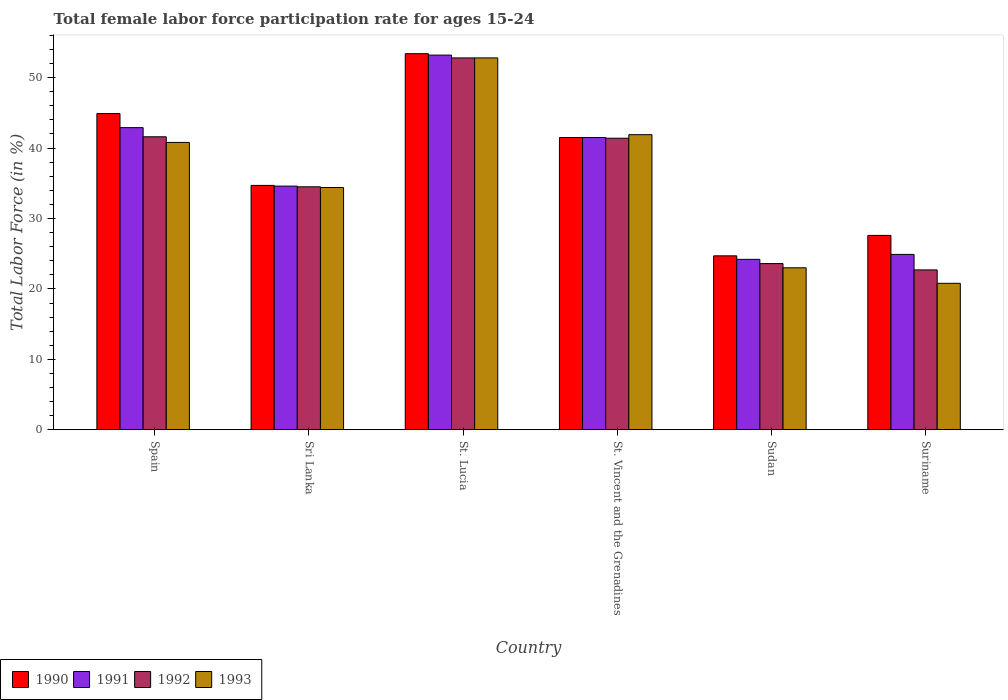How many groups of bars are there?
Make the answer very short. 6. Are the number of bars per tick equal to the number of legend labels?
Make the answer very short. Yes. Are the number of bars on each tick of the X-axis equal?
Your answer should be compact. Yes. How many bars are there on the 5th tick from the right?
Give a very brief answer. 4. What is the label of the 2nd group of bars from the left?
Provide a short and direct response. Sri Lanka. What is the female labor force participation rate in 1992 in Sri Lanka?
Offer a very short reply. 34.5. Across all countries, what is the maximum female labor force participation rate in 1991?
Your answer should be compact. 53.2. Across all countries, what is the minimum female labor force participation rate in 1990?
Make the answer very short. 24.7. In which country was the female labor force participation rate in 1990 maximum?
Offer a very short reply. St. Lucia. In which country was the female labor force participation rate in 1990 minimum?
Provide a succinct answer. Sudan. What is the total female labor force participation rate in 1991 in the graph?
Offer a very short reply. 221.3. What is the difference between the female labor force participation rate in 1992 in Spain and that in Suriname?
Offer a terse response. 18.9. What is the difference between the female labor force participation rate in 1991 in Sri Lanka and the female labor force participation rate in 1990 in Spain?
Provide a succinct answer. -10.3. What is the average female labor force participation rate in 1992 per country?
Ensure brevity in your answer.  36.1. What is the difference between the female labor force participation rate of/in 1991 and female labor force participation rate of/in 1992 in Suriname?
Offer a very short reply. 2.2. What is the ratio of the female labor force participation rate in 1991 in Sri Lanka to that in St. Vincent and the Grenadines?
Make the answer very short. 0.83. Is the female labor force participation rate in 1991 in Spain less than that in Sudan?
Your response must be concise. No. What is the difference between the highest and the second highest female labor force participation rate in 1993?
Keep it short and to the point. -1.1. What is the difference between the highest and the lowest female labor force participation rate in 1992?
Make the answer very short. 30.1. In how many countries, is the female labor force participation rate in 1991 greater than the average female labor force participation rate in 1991 taken over all countries?
Your response must be concise. 3. What does the 3rd bar from the left in Sudan represents?
Keep it short and to the point. 1992. Is it the case that in every country, the sum of the female labor force participation rate in 1993 and female labor force participation rate in 1992 is greater than the female labor force participation rate in 1990?
Your response must be concise. Yes. How many bars are there?
Ensure brevity in your answer.  24. What is the difference between two consecutive major ticks on the Y-axis?
Ensure brevity in your answer.  10. Are the values on the major ticks of Y-axis written in scientific E-notation?
Offer a terse response. No. How many legend labels are there?
Your response must be concise. 4. What is the title of the graph?
Your answer should be very brief. Total female labor force participation rate for ages 15-24. What is the label or title of the X-axis?
Provide a succinct answer. Country. What is the label or title of the Y-axis?
Make the answer very short. Total Labor Force (in %). What is the Total Labor Force (in %) in 1990 in Spain?
Offer a terse response. 44.9. What is the Total Labor Force (in %) of 1991 in Spain?
Your answer should be compact. 42.9. What is the Total Labor Force (in %) in 1992 in Spain?
Offer a very short reply. 41.6. What is the Total Labor Force (in %) of 1993 in Spain?
Make the answer very short. 40.8. What is the Total Labor Force (in %) of 1990 in Sri Lanka?
Your answer should be compact. 34.7. What is the Total Labor Force (in %) of 1991 in Sri Lanka?
Give a very brief answer. 34.6. What is the Total Labor Force (in %) in 1992 in Sri Lanka?
Give a very brief answer. 34.5. What is the Total Labor Force (in %) of 1993 in Sri Lanka?
Offer a terse response. 34.4. What is the Total Labor Force (in %) in 1990 in St. Lucia?
Provide a succinct answer. 53.4. What is the Total Labor Force (in %) of 1991 in St. Lucia?
Keep it short and to the point. 53.2. What is the Total Labor Force (in %) in 1992 in St. Lucia?
Make the answer very short. 52.8. What is the Total Labor Force (in %) in 1993 in St. Lucia?
Make the answer very short. 52.8. What is the Total Labor Force (in %) in 1990 in St. Vincent and the Grenadines?
Provide a succinct answer. 41.5. What is the Total Labor Force (in %) in 1991 in St. Vincent and the Grenadines?
Keep it short and to the point. 41.5. What is the Total Labor Force (in %) in 1992 in St. Vincent and the Grenadines?
Offer a very short reply. 41.4. What is the Total Labor Force (in %) of 1993 in St. Vincent and the Grenadines?
Give a very brief answer. 41.9. What is the Total Labor Force (in %) of 1990 in Sudan?
Your response must be concise. 24.7. What is the Total Labor Force (in %) of 1991 in Sudan?
Ensure brevity in your answer.  24.2. What is the Total Labor Force (in %) of 1992 in Sudan?
Offer a very short reply. 23.6. What is the Total Labor Force (in %) in 1993 in Sudan?
Your answer should be very brief. 23. What is the Total Labor Force (in %) in 1990 in Suriname?
Make the answer very short. 27.6. What is the Total Labor Force (in %) of 1991 in Suriname?
Offer a terse response. 24.9. What is the Total Labor Force (in %) in 1992 in Suriname?
Provide a short and direct response. 22.7. What is the Total Labor Force (in %) in 1993 in Suriname?
Offer a terse response. 20.8. Across all countries, what is the maximum Total Labor Force (in %) in 1990?
Your answer should be compact. 53.4. Across all countries, what is the maximum Total Labor Force (in %) in 1991?
Offer a very short reply. 53.2. Across all countries, what is the maximum Total Labor Force (in %) of 1992?
Your answer should be compact. 52.8. Across all countries, what is the maximum Total Labor Force (in %) of 1993?
Your answer should be compact. 52.8. Across all countries, what is the minimum Total Labor Force (in %) in 1990?
Make the answer very short. 24.7. Across all countries, what is the minimum Total Labor Force (in %) of 1991?
Offer a very short reply. 24.2. Across all countries, what is the minimum Total Labor Force (in %) of 1992?
Provide a succinct answer. 22.7. Across all countries, what is the minimum Total Labor Force (in %) of 1993?
Keep it short and to the point. 20.8. What is the total Total Labor Force (in %) of 1990 in the graph?
Give a very brief answer. 226.8. What is the total Total Labor Force (in %) of 1991 in the graph?
Provide a short and direct response. 221.3. What is the total Total Labor Force (in %) of 1992 in the graph?
Your answer should be compact. 216.6. What is the total Total Labor Force (in %) in 1993 in the graph?
Your response must be concise. 213.7. What is the difference between the Total Labor Force (in %) of 1990 in Spain and that in Sri Lanka?
Offer a terse response. 10.2. What is the difference between the Total Labor Force (in %) in 1990 in Spain and that in St. Lucia?
Provide a short and direct response. -8.5. What is the difference between the Total Labor Force (in %) of 1991 in Spain and that in St. Lucia?
Offer a terse response. -10.3. What is the difference between the Total Labor Force (in %) in 1992 in Spain and that in St. Lucia?
Your response must be concise. -11.2. What is the difference between the Total Labor Force (in %) in 1993 in Spain and that in St. Lucia?
Provide a short and direct response. -12. What is the difference between the Total Labor Force (in %) in 1991 in Spain and that in St. Vincent and the Grenadines?
Ensure brevity in your answer.  1.4. What is the difference between the Total Labor Force (in %) of 1992 in Spain and that in St. Vincent and the Grenadines?
Make the answer very short. 0.2. What is the difference between the Total Labor Force (in %) of 1993 in Spain and that in St. Vincent and the Grenadines?
Keep it short and to the point. -1.1. What is the difference between the Total Labor Force (in %) of 1990 in Spain and that in Sudan?
Your answer should be compact. 20.2. What is the difference between the Total Labor Force (in %) in 1992 in Spain and that in Sudan?
Offer a very short reply. 18. What is the difference between the Total Labor Force (in %) in 1990 in Spain and that in Suriname?
Provide a succinct answer. 17.3. What is the difference between the Total Labor Force (in %) of 1992 in Spain and that in Suriname?
Offer a very short reply. 18.9. What is the difference between the Total Labor Force (in %) in 1990 in Sri Lanka and that in St. Lucia?
Offer a terse response. -18.7. What is the difference between the Total Labor Force (in %) of 1991 in Sri Lanka and that in St. Lucia?
Give a very brief answer. -18.6. What is the difference between the Total Labor Force (in %) in 1992 in Sri Lanka and that in St. Lucia?
Give a very brief answer. -18.3. What is the difference between the Total Labor Force (in %) of 1993 in Sri Lanka and that in St. Lucia?
Make the answer very short. -18.4. What is the difference between the Total Labor Force (in %) of 1991 in Sri Lanka and that in St. Vincent and the Grenadines?
Keep it short and to the point. -6.9. What is the difference between the Total Labor Force (in %) of 1992 in Sri Lanka and that in St. Vincent and the Grenadines?
Ensure brevity in your answer.  -6.9. What is the difference between the Total Labor Force (in %) in 1993 in Sri Lanka and that in St. Vincent and the Grenadines?
Your response must be concise. -7.5. What is the difference between the Total Labor Force (in %) of 1991 in Sri Lanka and that in Sudan?
Ensure brevity in your answer.  10.4. What is the difference between the Total Labor Force (in %) in 1992 in Sri Lanka and that in Sudan?
Your response must be concise. 10.9. What is the difference between the Total Labor Force (in %) in 1993 in Sri Lanka and that in Sudan?
Your response must be concise. 11.4. What is the difference between the Total Labor Force (in %) of 1990 in Sri Lanka and that in Suriname?
Provide a short and direct response. 7.1. What is the difference between the Total Labor Force (in %) in 1991 in Sri Lanka and that in Suriname?
Provide a short and direct response. 9.7. What is the difference between the Total Labor Force (in %) of 1992 in Sri Lanka and that in Suriname?
Your response must be concise. 11.8. What is the difference between the Total Labor Force (in %) in 1990 in St. Lucia and that in St. Vincent and the Grenadines?
Give a very brief answer. 11.9. What is the difference between the Total Labor Force (in %) of 1992 in St. Lucia and that in St. Vincent and the Grenadines?
Offer a terse response. 11.4. What is the difference between the Total Labor Force (in %) in 1990 in St. Lucia and that in Sudan?
Provide a short and direct response. 28.7. What is the difference between the Total Labor Force (in %) of 1992 in St. Lucia and that in Sudan?
Your answer should be very brief. 29.2. What is the difference between the Total Labor Force (in %) in 1993 in St. Lucia and that in Sudan?
Your response must be concise. 29.8. What is the difference between the Total Labor Force (in %) in 1990 in St. Lucia and that in Suriname?
Your response must be concise. 25.8. What is the difference between the Total Labor Force (in %) of 1991 in St. Lucia and that in Suriname?
Offer a very short reply. 28.3. What is the difference between the Total Labor Force (in %) in 1992 in St. Lucia and that in Suriname?
Provide a succinct answer. 30.1. What is the difference between the Total Labor Force (in %) of 1990 in St. Vincent and the Grenadines and that in Sudan?
Keep it short and to the point. 16.8. What is the difference between the Total Labor Force (in %) of 1991 in St. Vincent and the Grenadines and that in Sudan?
Provide a short and direct response. 17.3. What is the difference between the Total Labor Force (in %) of 1990 in St. Vincent and the Grenadines and that in Suriname?
Offer a terse response. 13.9. What is the difference between the Total Labor Force (in %) of 1992 in St. Vincent and the Grenadines and that in Suriname?
Your answer should be very brief. 18.7. What is the difference between the Total Labor Force (in %) of 1993 in St. Vincent and the Grenadines and that in Suriname?
Your answer should be compact. 21.1. What is the difference between the Total Labor Force (in %) of 1990 in Sudan and that in Suriname?
Give a very brief answer. -2.9. What is the difference between the Total Labor Force (in %) of 1993 in Sudan and that in Suriname?
Ensure brevity in your answer.  2.2. What is the difference between the Total Labor Force (in %) in 1990 in Spain and the Total Labor Force (in %) in 1993 in Sri Lanka?
Offer a very short reply. 10.5. What is the difference between the Total Labor Force (in %) of 1991 in Spain and the Total Labor Force (in %) of 1993 in Sri Lanka?
Offer a terse response. 8.5. What is the difference between the Total Labor Force (in %) of 1990 in Spain and the Total Labor Force (in %) of 1991 in St. Lucia?
Your response must be concise. -8.3. What is the difference between the Total Labor Force (in %) in 1990 in Spain and the Total Labor Force (in %) in 1993 in St. Lucia?
Offer a terse response. -7.9. What is the difference between the Total Labor Force (in %) of 1991 in Spain and the Total Labor Force (in %) of 1992 in St. Lucia?
Your answer should be very brief. -9.9. What is the difference between the Total Labor Force (in %) in 1991 in Spain and the Total Labor Force (in %) in 1993 in St. Lucia?
Provide a succinct answer. -9.9. What is the difference between the Total Labor Force (in %) in 1990 in Spain and the Total Labor Force (in %) in 1992 in St. Vincent and the Grenadines?
Provide a succinct answer. 3.5. What is the difference between the Total Labor Force (in %) of 1991 in Spain and the Total Labor Force (in %) of 1992 in St. Vincent and the Grenadines?
Keep it short and to the point. 1.5. What is the difference between the Total Labor Force (in %) of 1990 in Spain and the Total Labor Force (in %) of 1991 in Sudan?
Keep it short and to the point. 20.7. What is the difference between the Total Labor Force (in %) in 1990 in Spain and the Total Labor Force (in %) in 1992 in Sudan?
Offer a terse response. 21.3. What is the difference between the Total Labor Force (in %) in 1990 in Spain and the Total Labor Force (in %) in 1993 in Sudan?
Your answer should be very brief. 21.9. What is the difference between the Total Labor Force (in %) in 1991 in Spain and the Total Labor Force (in %) in 1992 in Sudan?
Your answer should be compact. 19.3. What is the difference between the Total Labor Force (in %) in 1991 in Spain and the Total Labor Force (in %) in 1993 in Sudan?
Keep it short and to the point. 19.9. What is the difference between the Total Labor Force (in %) of 1990 in Spain and the Total Labor Force (in %) of 1992 in Suriname?
Your answer should be very brief. 22.2. What is the difference between the Total Labor Force (in %) of 1990 in Spain and the Total Labor Force (in %) of 1993 in Suriname?
Provide a short and direct response. 24.1. What is the difference between the Total Labor Force (in %) of 1991 in Spain and the Total Labor Force (in %) of 1992 in Suriname?
Your answer should be compact. 20.2. What is the difference between the Total Labor Force (in %) of 1991 in Spain and the Total Labor Force (in %) of 1993 in Suriname?
Offer a terse response. 22.1. What is the difference between the Total Labor Force (in %) of 1992 in Spain and the Total Labor Force (in %) of 1993 in Suriname?
Provide a succinct answer. 20.8. What is the difference between the Total Labor Force (in %) in 1990 in Sri Lanka and the Total Labor Force (in %) in 1991 in St. Lucia?
Offer a terse response. -18.5. What is the difference between the Total Labor Force (in %) of 1990 in Sri Lanka and the Total Labor Force (in %) of 1992 in St. Lucia?
Offer a terse response. -18.1. What is the difference between the Total Labor Force (in %) in 1990 in Sri Lanka and the Total Labor Force (in %) in 1993 in St. Lucia?
Give a very brief answer. -18.1. What is the difference between the Total Labor Force (in %) in 1991 in Sri Lanka and the Total Labor Force (in %) in 1992 in St. Lucia?
Provide a succinct answer. -18.2. What is the difference between the Total Labor Force (in %) in 1991 in Sri Lanka and the Total Labor Force (in %) in 1993 in St. Lucia?
Ensure brevity in your answer.  -18.2. What is the difference between the Total Labor Force (in %) of 1992 in Sri Lanka and the Total Labor Force (in %) of 1993 in St. Lucia?
Ensure brevity in your answer.  -18.3. What is the difference between the Total Labor Force (in %) of 1990 in Sri Lanka and the Total Labor Force (in %) of 1991 in St. Vincent and the Grenadines?
Provide a short and direct response. -6.8. What is the difference between the Total Labor Force (in %) of 1991 in Sri Lanka and the Total Labor Force (in %) of 1992 in St. Vincent and the Grenadines?
Offer a very short reply. -6.8. What is the difference between the Total Labor Force (in %) of 1990 in Sri Lanka and the Total Labor Force (in %) of 1991 in Sudan?
Offer a terse response. 10.5. What is the difference between the Total Labor Force (in %) of 1990 in Sri Lanka and the Total Labor Force (in %) of 1992 in Sudan?
Keep it short and to the point. 11.1. What is the difference between the Total Labor Force (in %) of 1990 in Sri Lanka and the Total Labor Force (in %) of 1993 in Sudan?
Provide a succinct answer. 11.7. What is the difference between the Total Labor Force (in %) of 1992 in Sri Lanka and the Total Labor Force (in %) of 1993 in Sudan?
Ensure brevity in your answer.  11.5. What is the difference between the Total Labor Force (in %) of 1990 in Sri Lanka and the Total Labor Force (in %) of 1991 in Suriname?
Ensure brevity in your answer.  9.8. What is the difference between the Total Labor Force (in %) of 1990 in Sri Lanka and the Total Labor Force (in %) of 1992 in Suriname?
Give a very brief answer. 12. What is the difference between the Total Labor Force (in %) in 1990 in Sri Lanka and the Total Labor Force (in %) in 1993 in Suriname?
Provide a succinct answer. 13.9. What is the difference between the Total Labor Force (in %) of 1991 in Sri Lanka and the Total Labor Force (in %) of 1992 in Suriname?
Keep it short and to the point. 11.9. What is the difference between the Total Labor Force (in %) of 1991 in Sri Lanka and the Total Labor Force (in %) of 1993 in Suriname?
Give a very brief answer. 13.8. What is the difference between the Total Labor Force (in %) in 1992 in Sri Lanka and the Total Labor Force (in %) in 1993 in Suriname?
Keep it short and to the point. 13.7. What is the difference between the Total Labor Force (in %) of 1990 in St. Lucia and the Total Labor Force (in %) of 1993 in St. Vincent and the Grenadines?
Offer a very short reply. 11.5. What is the difference between the Total Labor Force (in %) in 1991 in St. Lucia and the Total Labor Force (in %) in 1992 in St. Vincent and the Grenadines?
Offer a very short reply. 11.8. What is the difference between the Total Labor Force (in %) in 1991 in St. Lucia and the Total Labor Force (in %) in 1993 in St. Vincent and the Grenadines?
Offer a very short reply. 11.3. What is the difference between the Total Labor Force (in %) of 1992 in St. Lucia and the Total Labor Force (in %) of 1993 in St. Vincent and the Grenadines?
Ensure brevity in your answer.  10.9. What is the difference between the Total Labor Force (in %) in 1990 in St. Lucia and the Total Labor Force (in %) in 1991 in Sudan?
Make the answer very short. 29.2. What is the difference between the Total Labor Force (in %) in 1990 in St. Lucia and the Total Labor Force (in %) in 1992 in Sudan?
Offer a terse response. 29.8. What is the difference between the Total Labor Force (in %) of 1990 in St. Lucia and the Total Labor Force (in %) of 1993 in Sudan?
Your response must be concise. 30.4. What is the difference between the Total Labor Force (in %) in 1991 in St. Lucia and the Total Labor Force (in %) in 1992 in Sudan?
Your response must be concise. 29.6. What is the difference between the Total Labor Force (in %) of 1991 in St. Lucia and the Total Labor Force (in %) of 1993 in Sudan?
Give a very brief answer. 30.2. What is the difference between the Total Labor Force (in %) of 1992 in St. Lucia and the Total Labor Force (in %) of 1993 in Sudan?
Your response must be concise. 29.8. What is the difference between the Total Labor Force (in %) of 1990 in St. Lucia and the Total Labor Force (in %) of 1992 in Suriname?
Ensure brevity in your answer.  30.7. What is the difference between the Total Labor Force (in %) in 1990 in St. Lucia and the Total Labor Force (in %) in 1993 in Suriname?
Give a very brief answer. 32.6. What is the difference between the Total Labor Force (in %) in 1991 in St. Lucia and the Total Labor Force (in %) in 1992 in Suriname?
Ensure brevity in your answer.  30.5. What is the difference between the Total Labor Force (in %) in 1991 in St. Lucia and the Total Labor Force (in %) in 1993 in Suriname?
Keep it short and to the point. 32.4. What is the difference between the Total Labor Force (in %) in 1992 in St. Lucia and the Total Labor Force (in %) in 1993 in Suriname?
Provide a short and direct response. 32. What is the difference between the Total Labor Force (in %) of 1990 in St. Vincent and the Grenadines and the Total Labor Force (in %) of 1991 in Sudan?
Provide a short and direct response. 17.3. What is the difference between the Total Labor Force (in %) of 1990 in St. Vincent and the Grenadines and the Total Labor Force (in %) of 1993 in Sudan?
Provide a succinct answer. 18.5. What is the difference between the Total Labor Force (in %) of 1991 in St. Vincent and the Grenadines and the Total Labor Force (in %) of 1992 in Sudan?
Your answer should be compact. 17.9. What is the difference between the Total Labor Force (in %) of 1991 in St. Vincent and the Grenadines and the Total Labor Force (in %) of 1993 in Sudan?
Provide a short and direct response. 18.5. What is the difference between the Total Labor Force (in %) in 1990 in St. Vincent and the Grenadines and the Total Labor Force (in %) in 1991 in Suriname?
Provide a succinct answer. 16.6. What is the difference between the Total Labor Force (in %) of 1990 in St. Vincent and the Grenadines and the Total Labor Force (in %) of 1992 in Suriname?
Offer a very short reply. 18.8. What is the difference between the Total Labor Force (in %) of 1990 in St. Vincent and the Grenadines and the Total Labor Force (in %) of 1993 in Suriname?
Your answer should be very brief. 20.7. What is the difference between the Total Labor Force (in %) of 1991 in St. Vincent and the Grenadines and the Total Labor Force (in %) of 1993 in Suriname?
Ensure brevity in your answer.  20.7. What is the difference between the Total Labor Force (in %) of 1992 in St. Vincent and the Grenadines and the Total Labor Force (in %) of 1993 in Suriname?
Provide a succinct answer. 20.6. What is the difference between the Total Labor Force (in %) of 1990 in Sudan and the Total Labor Force (in %) of 1992 in Suriname?
Make the answer very short. 2. What is the difference between the Total Labor Force (in %) of 1990 in Sudan and the Total Labor Force (in %) of 1993 in Suriname?
Provide a short and direct response. 3.9. What is the difference between the Total Labor Force (in %) of 1991 in Sudan and the Total Labor Force (in %) of 1992 in Suriname?
Your answer should be compact. 1.5. What is the difference between the Total Labor Force (in %) of 1991 in Sudan and the Total Labor Force (in %) of 1993 in Suriname?
Keep it short and to the point. 3.4. What is the average Total Labor Force (in %) in 1990 per country?
Your answer should be very brief. 37.8. What is the average Total Labor Force (in %) in 1991 per country?
Offer a very short reply. 36.88. What is the average Total Labor Force (in %) in 1992 per country?
Your answer should be compact. 36.1. What is the average Total Labor Force (in %) of 1993 per country?
Give a very brief answer. 35.62. What is the difference between the Total Labor Force (in %) of 1990 and Total Labor Force (in %) of 1991 in Spain?
Your answer should be very brief. 2. What is the difference between the Total Labor Force (in %) of 1990 and Total Labor Force (in %) of 1992 in Spain?
Make the answer very short. 3.3. What is the difference between the Total Labor Force (in %) in 1990 and Total Labor Force (in %) in 1993 in Spain?
Your response must be concise. 4.1. What is the difference between the Total Labor Force (in %) of 1991 and Total Labor Force (in %) of 1992 in Spain?
Make the answer very short. 1.3. What is the difference between the Total Labor Force (in %) of 1992 and Total Labor Force (in %) of 1993 in Spain?
Provide a succinct answer. 0.8. What is the difference between the Total Labor Force (in %) in 1990 and Total Labor Force (in %) in 1992 in Sri Lanka?
Ensure brevity in your answer.  0.2. What is the difference between the Total Labor Force (in %) of 1991 and Total Labor Force (in %) of 1993 in Sri Lanka?
Offer a very short reply. 0.2. What is the difference between the Total Labor Force (in %) in 1990 and Total Labor Force (in %) in 1992 in St. Lucia?
Your answer should be very brief. 0.6. What is the difference between the Total Labor Force (in %) in 1990 and Total Labor Force (in %) in 1993 in St. Lucia?
Make the answer very short. 0.6. What is the difference between the Total Labor Force (in %) of 1990 and Total Labor Force (in %) of 1993 in St. Vincent and the Grenadines?
Offer a terse response. -0.4. What is the difference between the Total Labor Force (in %) in 1991 and Total Labor Force (in %) in 1992 in St. Vincent and the Grenadines?
Give a very brief answer. 0.1. What is the difference between the Total Labor Force (in %) of 1991 and Total Labor Force (in %) of 1993 in St. Vincent and the Grenadines?
Your response must be concise. -0.4. What is the difference between the Total Labor Force (in %) in 1990 and Total Labor Force (in %) in 1991 in Sudan?
Your answer should be compact. 0.5. What is the difference between the Total Labor Force (in %) of 1991 and Total Labor Force (in %) of 1992 in Sudan?
Your response must be concise. 0.6. What is the difference between the Total Labor Force (in %) in 1990 and Total Labor Force (in %) in 1991 in Suriname?
Provide a short and direct response. 2.7. What is the difference between the Total Labor Force (in %) of 1990 and Total Labor Force (in %) of 1992 in Suriname?
Make the answer very short. 4.9. What is the ratio of the Total Labor Force (in %) of 1990 in Spain to that in Sri Lanka?
Make the answer very short. 1.29. What is the ratio of the Total Labor Force (in %) of 1991 in Spain to that in Sri Lanka?
Your answer should be compact. 1.24. What is the ratio of the Total Labor Force (in %) in 1992 in Spain to that in Sri Lanka?
Your response must be concise. 1.21. What is the ratio of the Total Labor Force (in %) of 1993 in Spain to that in Sri Lanka?
Offer a very short reply. 1.19. What is the ratio of the Total Labor Force (in %) of 1990 in Spain to that in St. Lucia?
Offer a terse response. 0.84. What is the ratio of the Total Labor Force (in %) in 1991 in Spain to that in St. Lucia?
Make the answer very short. 0.81. What is the ratio of the Total Labor Force (in %) of 1992 in Spain to that in St. Lucia?
Offer a very short reply. 0.79. What is the ratio of the Total Labor Force (in %) of 1993 in Spain to that in St. Lucia?
Offer a terse response. 0.77. What is the ratio of the Total Labor Force (in %) of 1990 in Spain to that in St. Vincent and the Grenadines?
Keep it short and to the point. 1.08. What is the ratio of the Total Labor Force (in %) of 1991 in Spain to that in St. Vincent and the Grenadines?
Offer a very short reply. 1.03. What is the ratio of the Total Labor Force (in %) of 1993 in Spain to that in St. Vincent and the Grenadines?
Your answer should be very brief. 0.97. What is the ratio of the Total Labor Force (in %) in 1990 in Spain to that in Sudan?
Your answer should be very brief. 1.82. What is the ratio of the Total Labor Force (in %) in 1991 in Spain to that in Sudan?
Keep it short and to the point. 1.77. What is the ratio of the Total Labor Force (in %) of 1992 in Spain to that in Sudan?
Your response must be concise. 1.76. What is the ratio of the Total Labor Force (in %) in 1993 in Spain to that in Sudan?
Keep it short and to the point. 1.77. What is the ratio of the Total Labor Force (in %) in 1990 in Spain to that in Suriname?
Provide a succinct answer. 1.63. What is the ratio of the Total Labor Force (in %) of 1991 in Spain to that in Suriname?
Make the answer very short. 1.72. What is the ratio of the Total Labor Force (in %) in 1992 in Spain to that in Suriname?
Ensure brevity in your answer.  1.83. What is the ratio of the Total Labor Force (in %) in 1993 in Spain to that in Suriname?
Your answer should be very brief. 1.96. What is the ratio of the Total Labor Force (in %) in 1990 in Sri Lanka to that in St. Lucia?
Ensure brevity in your answer.  0.65. What is the ratio of the Total Labor Force (in %) in 1991 in Sri Lanka to that in St. Lucia?
Ensure brevity in your answer.  0.65. What is the ratio of the Total Labor Force (in %) in 1992 in Sri Lanka to that in St. Lucia?
Offer a very short reply. 0.65. What is the ratio of the Total Labor Force (in %) in 1993 in Sri Lanka to that in St. Lucia?
Offer a very short reply. 0.65. What is the ratio of the Total Labor Force (in %) in 1990 in Sri Lanka to that in St. Vincent and the Grenadines?
Give a very brief answer. 0.84. What is the ratio of the Total Labor Force (in %) in 1991 in Sri Lanka to that in St. Vincent and the Grenadines?
Keep it short and to the point. 0.83. What is the ratio of the Total Labor Force (in %) in 1993 in Sri Lanka to that in St. Vincent and the Grenadines?
Offer a terse response. 0.82. What is the ratio of the Total Labor Force (in %) in 1990 in Sri Lanka to that in Sudan?
Offer a very short reply. 1.4. What is the ratio of the Total Labor Force (in %) in 1991 in Sri Lanka to that in Sudan?
Offer a very short reply. 1.43. What is the ratio of the Total Labor Force (in %) in 1992 in Sri Lanka to that in Sudan?
Keep it short and to the point. 1.46. What is the ratio of the Total Labor Force (in %) of 1993 in Sri Lanka to that in Sudan?
Your response must be concise. 1.5. What is the ratio of the Total Labor Force (in %) in 1990 in Sri Lanka to that in Suriname?
Provide a short and direct response. 1.26. What is the ratio of the Total Labor Force (in %) in 1991 in Sri Lanka to that in Suriname?
Keep it short and to the point. 1.39. What is the ratio of the Total Labor Force (in %) in 1992 in Sri Lanka to that in Suriname?
Your response must be concise. 1.52. What is the ratio of the Total Labor Force (in %) in 1993 in Sri Lanka to that in Suriname?
Your response must be concise. 1.65. What is the ratio of the Total Labor Force (in %) in 1990 in St. Lucia to that in St. Vincent and the Grenadines?
Offer a very short reply. 1.29. What is the ratio of the Total Labor Force (in %) of 1991 in St. Lucia to that in St. Vincent and the Grenadines?
Provide a short and direct response. 1.28. What is the ratio of the Total Labor Force (in %) of 1992 in St. Lucia to that in St. Vincent and the Grenadines?
Provide a short and direct response. 1.28. What is the ratio of the Total Labor Force (in %) in 1993 in St. Lucia to that in St. Vincent and the Grenadines?
Make the answer very short. 1.26. What is the ratio of the Total Labor Force (in %) in 1990 in St. Lucia to that in Sudan?
Your answer should be very brief. 2.16. What is the ratio of the Total Labor Force (in %) in 1991 in St. Lucia to that in Sudan?
Make the answer very short. 2.2. What is the ratio of the Total Labor Force (in %) in 1992 in St. Lucia to that in Sudan?
Keep it short and to the point. 2.24. What is the ratio of the Total Labor Force (in %) in 1993 in St. Lucia to that in Sudan?
Offer a very short reply. 2.3. What is the ratio of the Total Labor Force (in %) in 1990 in St. Lucia to that in Suriname?
Offer a terse response. 1.93. What is the ratio of the Total Labor Force (in %) of 1991 in St. Lucia to that in Suriname?
Provide a succinct answer. 2.14. What is the ratio of the Total Labor Force (in %) of 1992 in St. Lucia to that in Suriname?
Make the answer very short. 2.33. What is the ratio of the Total Labor Force (in %) in 1993 in St. Lucia to that in Suriname?
Offer a very short reply. 2.54. What is the ratio of the Total Labor Force (in %) in 1990 in St. Vincent and the Grenadines to that in Sudan?
Make the answer very short. 1.68. What is the ratio of the Total Labor Force (in %) in 1991 in St. Vincent and the Grenadines to that in Sudan?
Keep it short and to the point. 1.71. What is the ratio of the Total Labor Force (in %) of 1992 in St. Vincent and the Grenadines to that in Sudan?
Your answer should be compact. 1.75. What is the ratio of the Total Labor Force (in %) in 1993 in St. Vincent and the Grenadines to that in Sudan?
Your answer should be compact. 1.82. What is the ratio of the Total Labor Force (in %) in 1990 in St. Vincent and the Grenadines to that in Suriname?
Your answer should be very brief. 1.5. What is the ratio of the Total Labor Force (in %) in 1992 in St. Vincent and the Grenadines to that in Suriname?
Your answer should be very brief. 1.82. What is the ratio of the Total Labor Force (in %) in 1993 in St. Vincent and the Grenadines to that in Suriname?
Your answer should be very brief. 2.01. What is the ratio of the Total Labor Force (in %) in 1990 in Sudan to that in Suriname?
Provide a short and direct response. 0.89. What is the ratio of the Total Labor Force (in %) of 1991 in Sudan to that in Suriname?
Your answer should be very brief. 0.97. What is the ratio of the Total Labor Force (in %) of 1992 in Sudan to that in Suriname?
Your answer should be very brief. 1.04. What is the ratio of the Total Labor Force (in %) in 1993 in Sudan to that in Suriname?
Provide a succinct answer. 1.11. What is the difference between the highest and the second highest Total Labor Force (in %) in 1991?
Give a very brief answer. 10.3. What is the difference between the highest and the lowest Total Labor Force (in %) of 1990?
Your response must be concise. 28.7. What is the difference between the highest and the lowest Total Labor Force (in %) of 1992?
Your answer should be very brief. 30.1. 